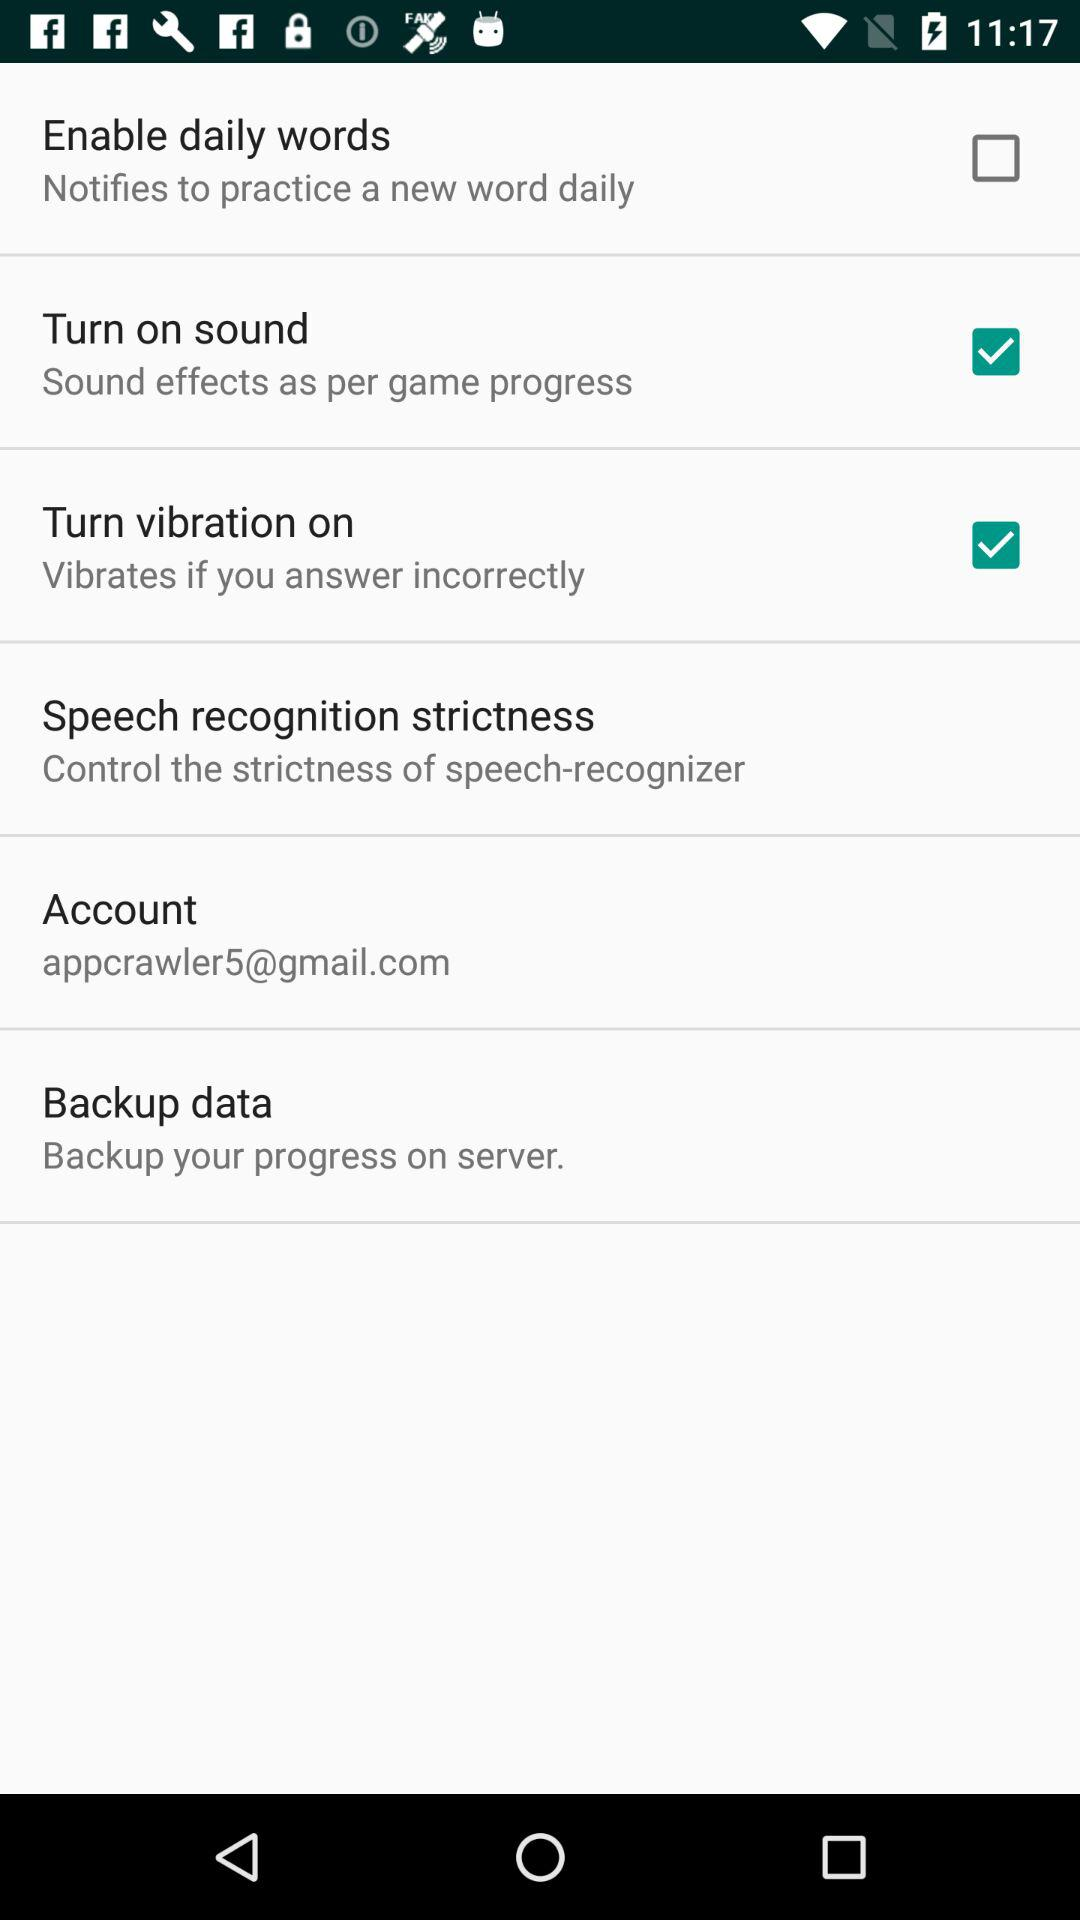What is the email address? The email address is appcrawler5@gmail.com. 